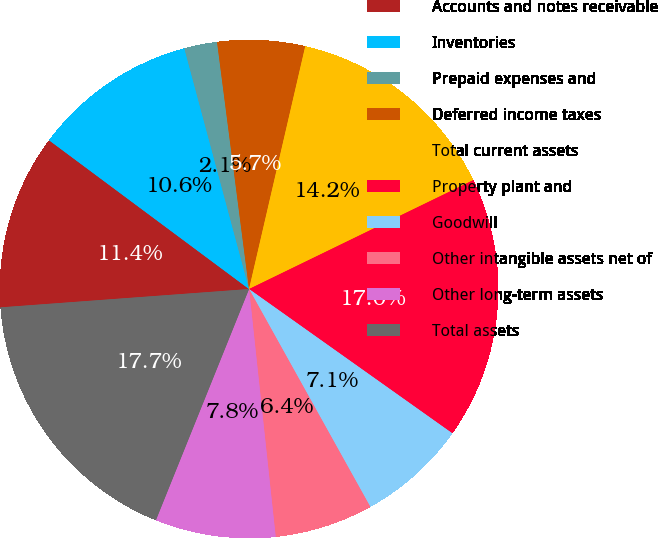Convert chart to OTSL. <chart><loc_0><loc_0><loc_500><loc_500><pie_chart><fcel>Accounts and notes receivable<fcel>Inventories<fcel>Prepaid expenses and<fcel>Deferred income taxes<fcel>Total current assets<fcel>Property plant and<fcel>Goodwill<fcel>Other intangible assets net of<fcel>Other long-term assets<fcel>Total assets<nl><fcel>11.35%<fcel>10.64%<fcel>2.13%<fcel>5.67%<fcel>14.18%<fcel>17.02%<fcel>7.09%<fcel>6.38%<fcel>7.8%<fcel>17.73%<nl></chart> 